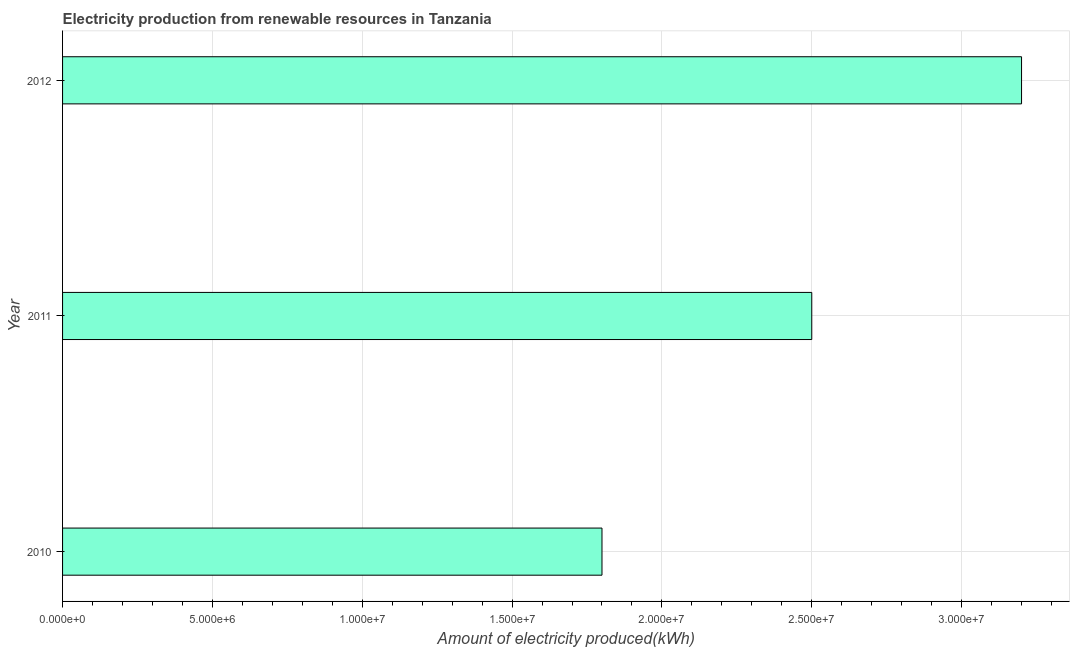Does the graph contain grids?
Keep it short and to the point. Yes. What is the title of the graph?
Make the answer very short. Electricity production from renewable resources in Tanzania. What is the label or title of the X-axis?
Keep it short and to the point. Amount of electricity produced(kWh). What is the label or title of the Y-axis?
Make the answer very short. Year. What is the amount of electricity produced in 2010?
Your response must be concise. 1.80e+07. Across all years, what is the maximum amount of electricity produced?
Give a very brief answer. 3.20e+07. Across all years, what is the minimum amount of electricity produced?
Make the answer very short. 1.80e+07. What is the sum of the amount of electricity produced?
Provide a short and direct response. 7.50e+07. What is the difference between the amount of electricity produced in 2010 and 2011?
Offer a terse response. -7.00e+06. What is the average amount of electricity produced per year?
Your answer should be compact. 2.50e+07. What is the median amount of electricity produced?
Your answer should be compact. 2.50e+07. In how many years, is the amount of electricity produced greater than 28000000 kWh?
Give a very brief answer. 1. What is the ratio of the amount of electricity produced in 2011 to that in 2012?
Offer a terse response. 0.78. Is the difference between the amount of electricity produced in 2011 and 2012 greater than the difference between any two years?
Offer a very short reply. No. What is the difference between the highest and the second highest amount of electricity produced?
Make the answer very short. 7.00e+06. What is the difference between the highest and the lowest amount of electricity produced?
Make the answer very short. 1.40e+07. In how many years, is the amount of electricity produced greater than the average amount of electricity produced taken over all years?
Offer a terse response. 1. How many bars are there?
Offer a very short reply. 3. What is the Amount of electricity produced(kWh) of 2010?
Offer a terse response. 1.80e+07. What is the Amount of electricity produced(kWh) of 2011?
Your answer should be compact. 2.50e+07. What is the Amount of electricity produced(kWh) of 2012?
Provide a short and direct response. 3.20e+07. What is the difference between the Amount of electricity produced(kWh) in 2010 and 2011?
Ensure brevity in your answer.  -7.00e+06. What is the difference between the Amount of electricity produced(kWh) in 2010 and 2012?
Keep it short and to the point. -1.40e+07. What is the difference between the Amount of electricity produced(kWh) in 2011 and 2012?
Make the answer very short. -7.00e+06. What is the ratio of the Amount of electricity produced(kWh) in 2010 to that in 2011?
Provide a succinct answer. 0.72. What is the ratio of the Amount of electricity produced(kWh) in 2010 to that in 2012?
Make the answer very short. 0.56. What is the ratio of the Amount of electricity produced(kWh) in 2011 to that in 2012?
Provide a succinct answer. 0.78. 